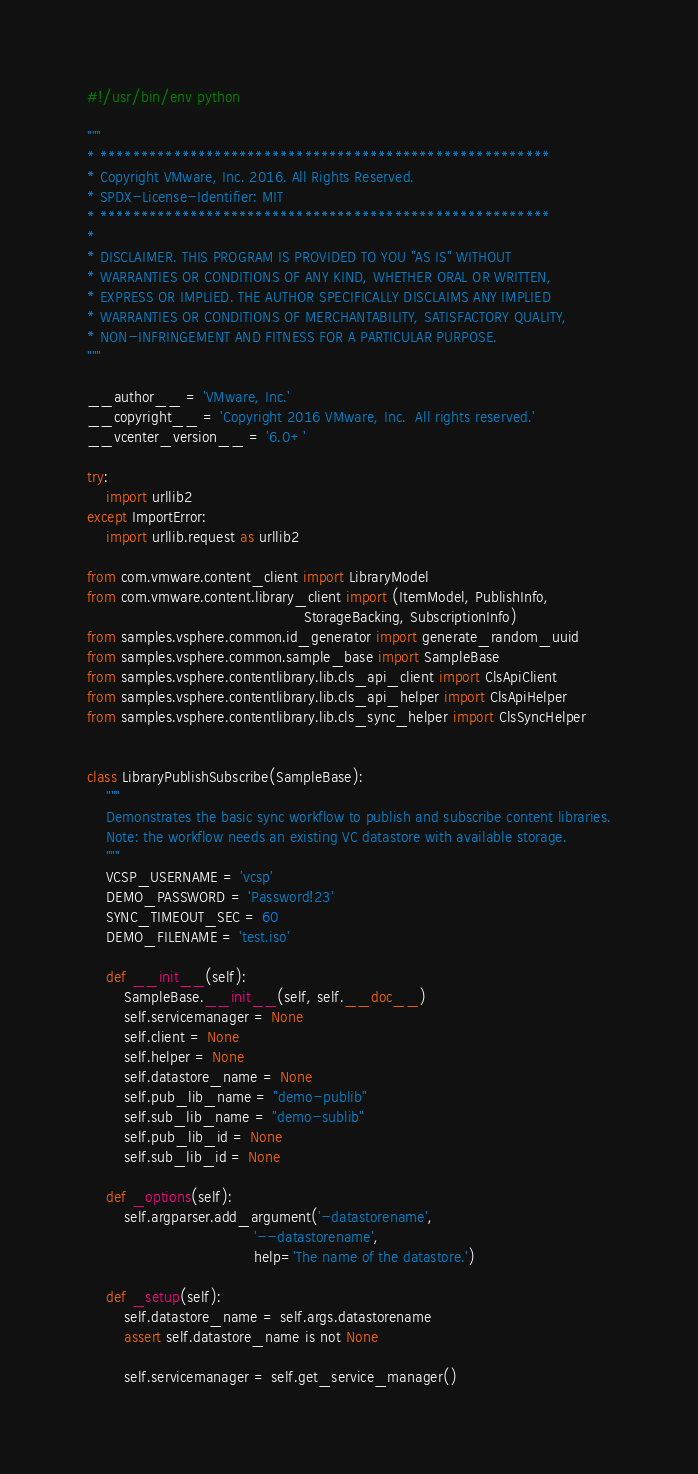<code> <loc_0><loc_0><loc_500><loc_500><_Python_>#!/usr/bin/env python

"""
* *******************************************************
* Copyright VMware, Inc. 2016. All Rights Reserved.
* SPDX-License-Identifier: MIT
* *******************************************************
*
* DISCLAIMER. THIS PROGRAM IS PROVIDED TO YOU "AS IS" WITHOUT
* WARRANTIES OR CONDITIONS OF ANY KIND, WHETHER ORAL OR WRITTEN,
* EXPRESS OR IMPLIED. THE AUTHOR SPECIFICALLY DISCLAIMS ANY IMPLIED
* WARRANTIES OR CONDITIONS OF MERCHANTABILITY, SATISFACTORY QUALITY,
* NON-INFRINGEMENT AND FITNESS FOR A PARTICULAR PURPOSE.
"""

__author__ = 'VMware, Inc.'
__copyright__ = 'Copyright 2016 VMware, Inc.  All rights reserved.'
__vcenter_version__ = '6.0+'

try:
    import urllib2
except ImportError:
    import urllib.request as urllib2

from com.vmware.content_client import LibraryModel
from com.vmware.content.library_client import (ItemModel, PublishInfo,
                                               StorageBacking, SubscriptionInfo)
from samples.vsphere.common.id_generator import generate_random_uuid
from samples.vsphere.common.sample_base import SampleBase
from samples.vsphere.contentlibrary.lib.cls_api_client import ClsApiClient
from samples.vsphere.contentlibrary.lib.cls_api_helper import ClsApiHelper
from samples.vsphere.contentlibrary.lib.cls_sync_helper import ClsSyncHelper


class LibraryPublishSubscribe(SampleBase):
    """
    Demonstrates the basic sync workflow to publish and subscribe content libraries.
    Note: the workflow needs an existing VC datastore with available storage.
    """
    VCSP_USERNAME = 'vcsp'
    DEMO_PASSWORD = 'Password!23'
    SYNC_TIMEOUT_SEC = 60
    DEMO_FILENAME = 'test.iso'

    def __init__(self):
        SampleBase.__init__(self, self.__doc__)
        self.servicemanager = None
        self.client = None
        self.helper = None
        self.datastore_name = None
        self.pub_lib_name = "demo-publib"
        self.sub_lib_name = "demo-sublib"
        self.pub_lib_id = None
        self.sub_lib_id = None

    def _options(self):
        self.argparser.add_argument('-datastorename',
                                    '--datastorename',
                                    help='The name of the datastore.')

    def _setup(self):
        self.datastore_name = self.args.datastorename
        assert self.datastore_name is not None

        self.servicemanager = self.get_service_manager()</code> 